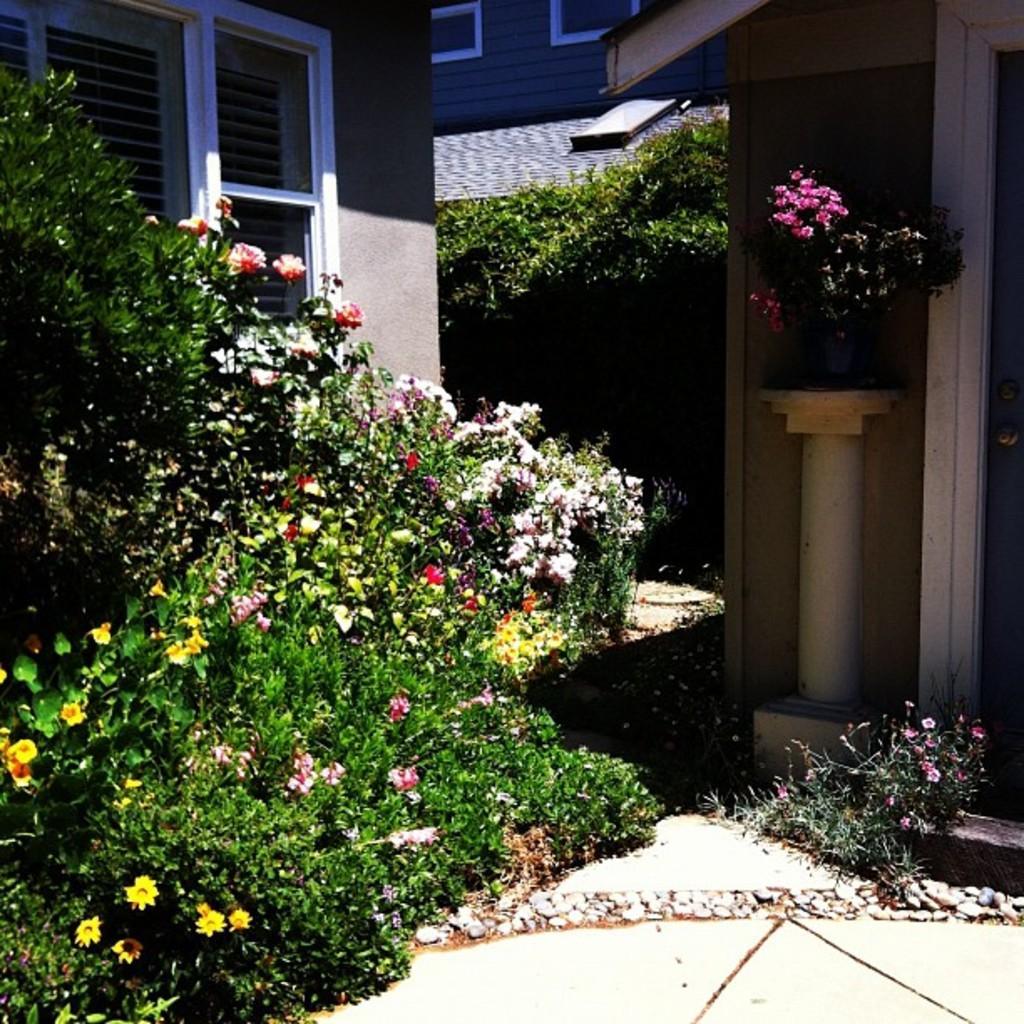How would you summarize this image in a sentence or two? In this picture we can see plants with flowers, here we can see a pot on a platform and in the background we can see buildings with windows. 